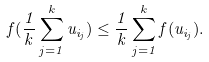Convert formula to latex. <formula><loc_0><loc_0><loc_500><loc_500>f ( \frac { 1 } { k } \sum _ { j = 1 } ^ { k } u _ { i _ { j } } ) \leq \frac { 1 } { k } \sum _ { j = 1 } ^ { k } f ( u _ { i _ { j } } ) .</formula> 